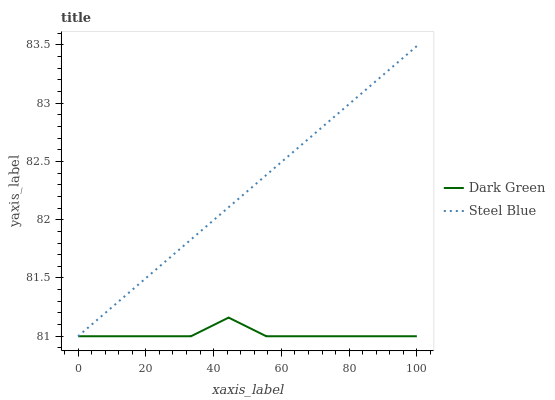Does Dark Green have the maximum area under the curve?
Answer yes or no. No. Is Dark Green the smoothest?
Answer yes or no. No. Does Dark Green have the highest value?
Answer yes or no. No. 